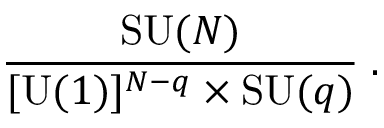<formula> <loc_0><loc_0><loc_500><loc_500>{ \frac { S U ( N ) } { [ U ( 1 ) ] ^ { N - q } \times S U ( q ) } } \, .</formula> 